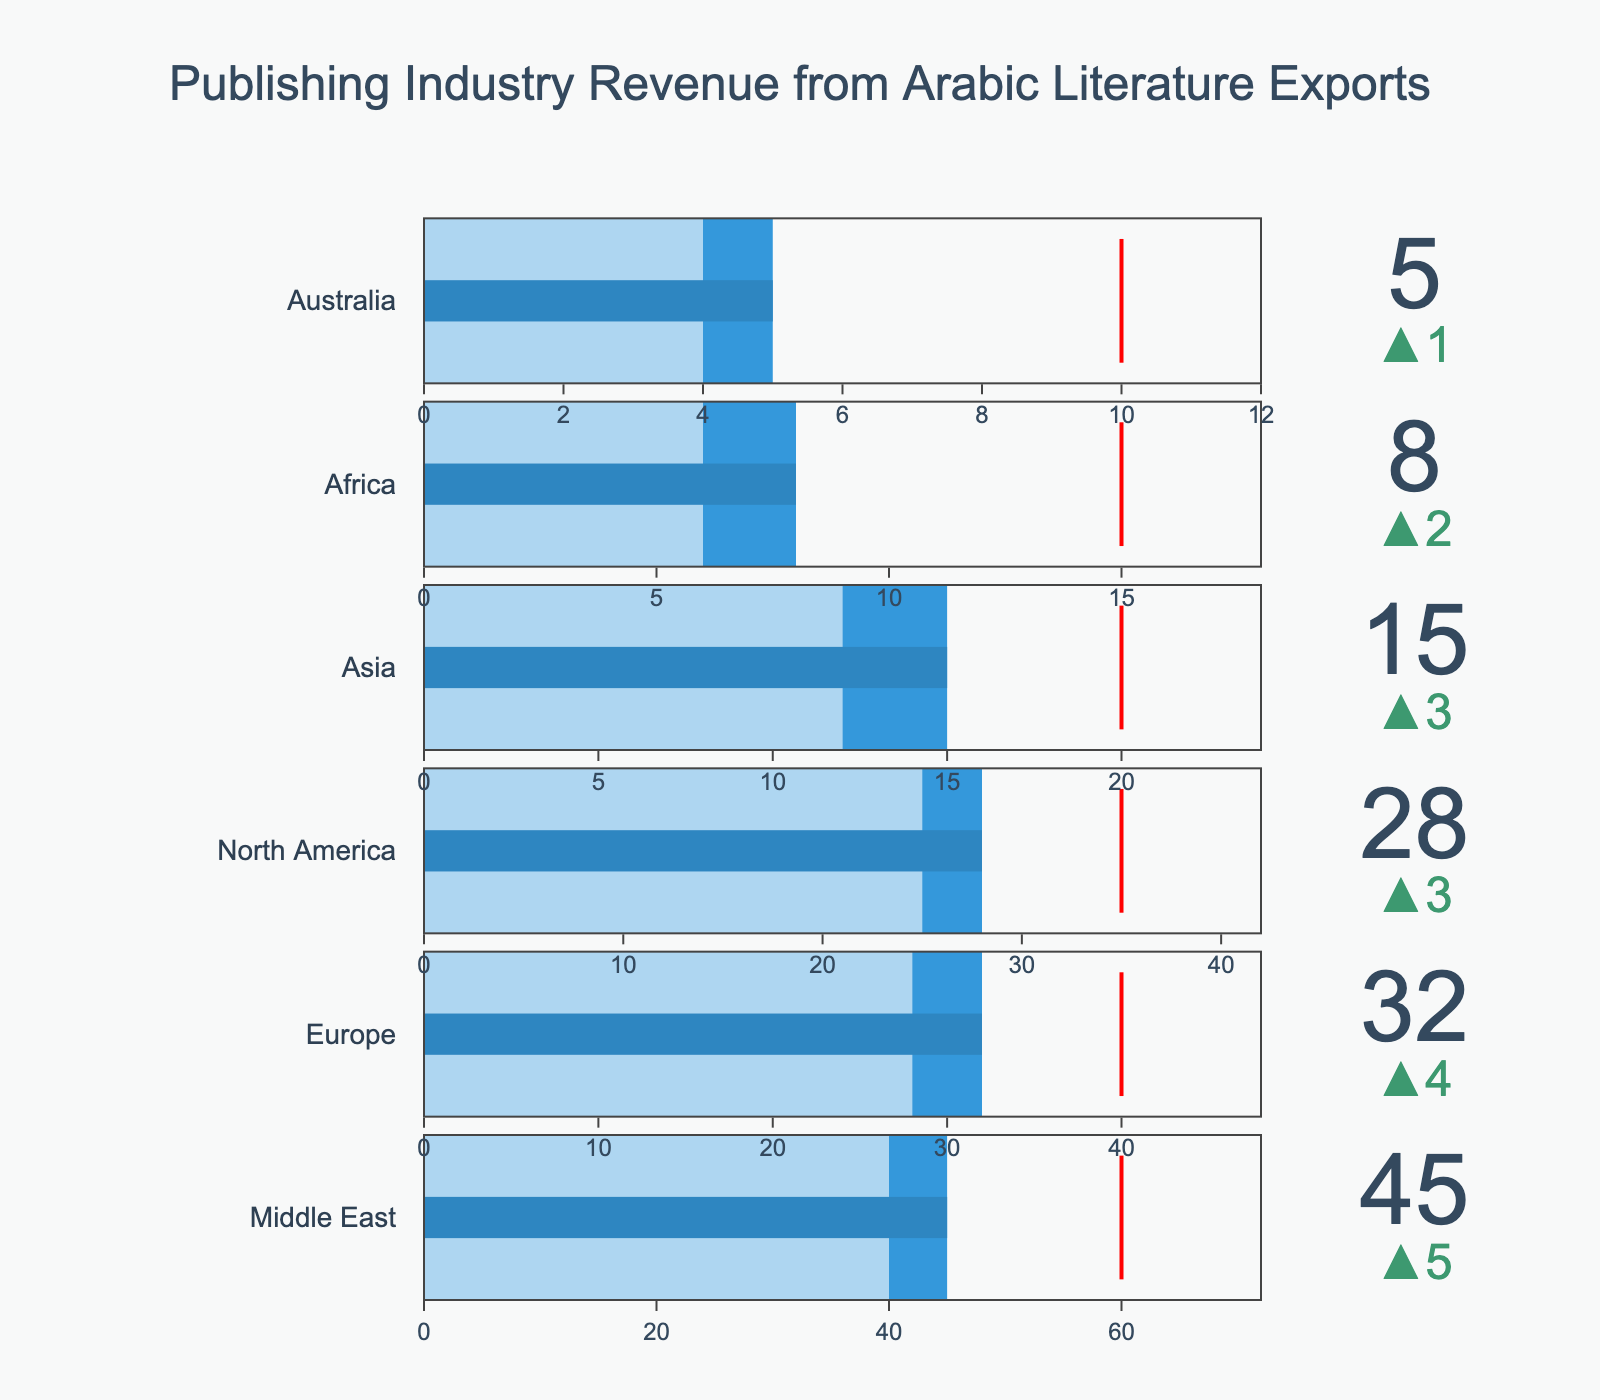what is the title of this chart? The title is displayed prominently at the top of the chart. It reads "Publishing Industry Revenue from Arabic Literature Exports".
Answer: Publishing Industry Revenue from Arabic Literature Exports Which region has the highest actual revenue? In the figure, the bullet chart shows that the Middle East has the highest actual revenue, as it is positioned first when sorted by actual revenue.
Answer: Middle East What is the actual revenue for North America? The actual revenue for each region is displayed on the bullet chart. For North America, it is indicated as 28.
Answer: 28 Which region has the smallest gap between actual revenue and target revenue? To determine the smallest gap, compare the actual revenues and target revenues. Africa has the target at 15 and actual at 8, a gap of 7, which is the smallest among the regions.
Answer: Africa By how much did Europe's actual revenue exceed its previous year revenue? Europe's actual revenue is 32, and its previous year revenue is 28. Subtracting the previous year revenue from the actual revenue gives the difference: 32 - 28 = 4.
Answer: 4 Which region had the largest increase in actual revenue compared to the previous year? The bullet chart shows deltas indicating changes. The Middle East had an increase from 40 to 45, which is 5, more than any other region.
Answer: Middle East What's the overall target revenue for all regions combined? The target revenues for all regions are: Middle East (60), Europe (40), North America (35), Asia (20), Africa (15), and Australia (10). Summing these values gives: 60 + 40 + 35 + 20 + 15 + 10 = 180.
Answer: 180 How many regions did not meet their target revenue? By comparing actual revenues to target revenues for each region, we see that all regions (Middle East, Europe, North America, Asia, Africa, and Australia) did not meet their targets.
Answer: 6 What is the difference between the actual revenues of the Middle East and North America? The actual revenue for the Middle East is 45, and for North America, it is 28. The difference is: 45 - 28 = 17.
Answer: 17 Which region's actual revenue is closest to its previous year revenue? By comparing the deltas, Australia has the smallest increase from 4 to 5, a difference of 1, making it the closest to its previous year revenue.
Answer: Australia 